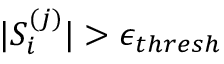<formula> <loc_0><loc_0><loc_500><loc_500>| S _ { i } ^ { ( j ) } | > \epsilon _ { t h r e s h }</formula> 